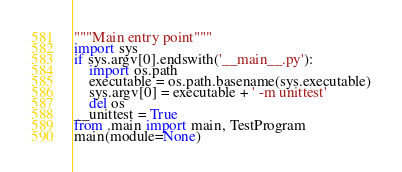<code> <loc_0><loc_0><loc_500><loc_500><_Python_>"""Main entry point"""
import sys
if sys.argv[0].endswith('__main__.py'):
    import os.path
    executable = os.path.basename(sys.executable)
    sys.argv[0] = executable + ' -m unittest'
    del os
__unittest = True
from .main import main, TestProgram
main(module=None)
</code> 